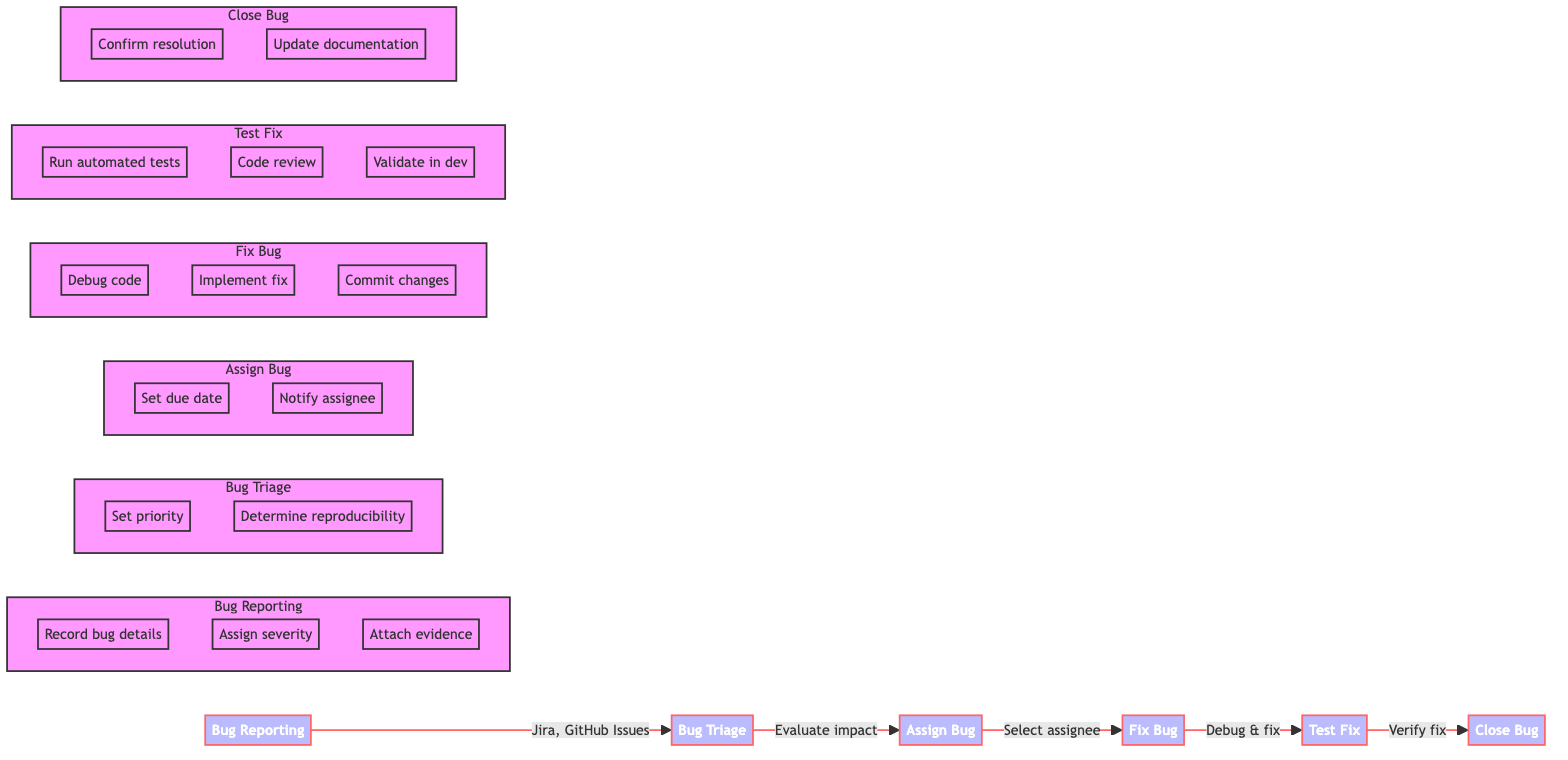What is the first step in the process? The diagram indicates that the first step is "Bug Reporting". This can be seen as the starting point and is the leftmost element in the flowchart.
Answer: Bug Reporting Which tools are used in the Bug Triage step? Looking into the Bug Triage section of the diagram, the tools listed are "Jira" and "Trello". These tools facilitate the categorization and prioritization of bugs during this step.
Answer: Jira, Trello How many actions are associated with fixing a bug? In the "Fix Bug" section of the flowchart, there are three specific actions mentioned: "Debug code", "Write fix", and "Commit changes". Counting these actions gives a total of three.
Answer: 3 What comes after testing the fix? According to the flowchart, the step that follows "Test Fix" is "Close Bug". This shows the progression from verifying the fix to finalizing the bug resolution.
Answer: Close Bug What is the description of the Assign Bug step? The description in the flowchart for the "Assign Bug" step states it is to "Allocate the bug to a developer or team for resolution". This describes the main purpose of this step in the process.
Answer: Allocate the bug to a developer or team for resolution How many sub-steps are included in the Bug Reporting phase? Within the Bug Reporting section, there are three sub-steps specified: "Record bug details", "Assign severity", and "Attach evidence". This indicates a total of three tasks associated with reporting a bug.
Answer: 3 Which action verifies that the bug fix resolves the issue? The action listed in the "Test Fix" section that serves this purpose is "Verify fix". This indicates that part of the testing process is dedicated to confirming the effectiveness of the fix.
Answer: Verify fix What is the main goal of the Bug Triage step? The main goal, as described in the diagram, is to "Prioritize and categorize the reported bug". This answer summarizes the primary function of the Bug Triage phase in bug tracking.
Answer: Prioritize and categorize the reported bug How does the flowchart depict the relationship between Bug Reporting and Bug Triage? The flowchart shows a direct arrow leading from "Bug Reporting" to "Bug Triage", indicating that the process flows sequentially from reporting a bug to the triage of that bug.
Answer: Direct arrow 